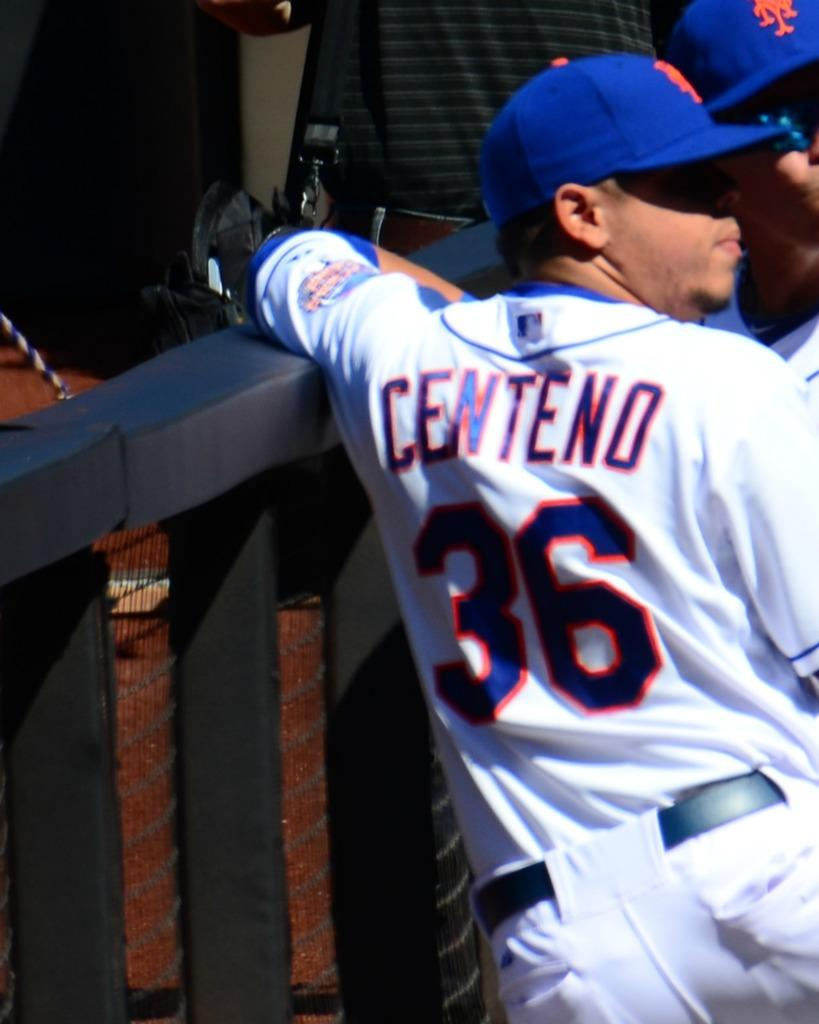<image>
Give a short and clear explanation of the subsequent image. The player shown here has the number 36 on his back 